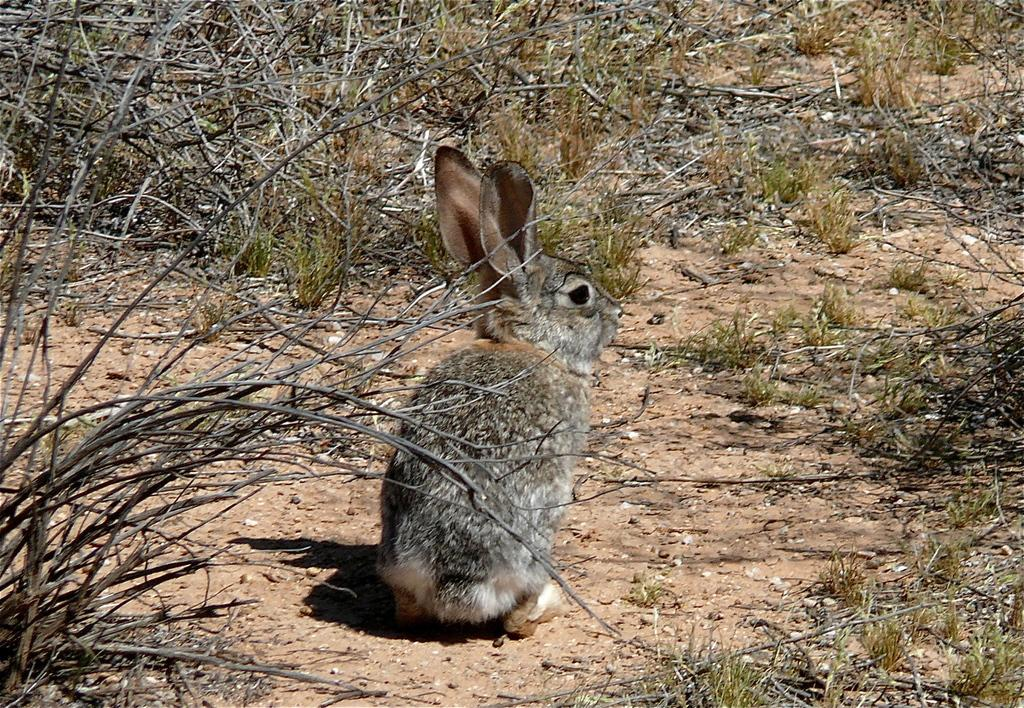What animal is present in the image? There is a rabbit in the image. What is the rabbit doing in the image? The rabbit is sitting on the ground. What type of vegetation is present around the rabbit? There are dry plants around the rabbit. What type of ground cover can be seen in the image? There is grass in the image. What additional plant material is present in the image? There are dry leaves in the image. How does the rabbit use the chin to catch water during the rainstorm in the image? There is no rainstorm present in the image, and the rabbit is not using its chin to catch water. 